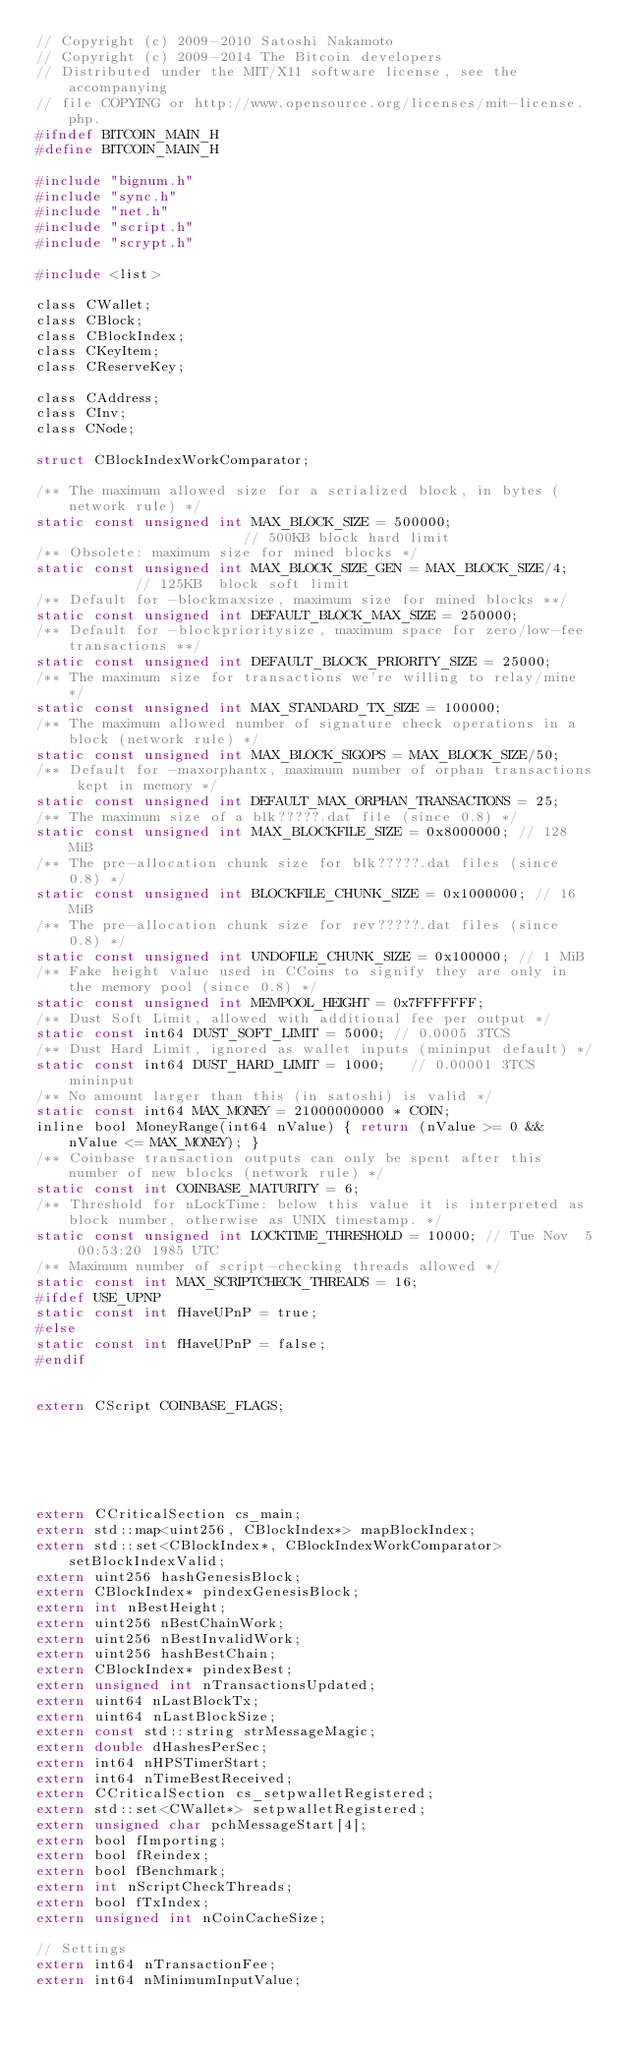<code> <loc_0><loc_0><loc_500><loc_500><_C_>// Copyright (c) 2009-2010 Satoshi Nakamoto
// Copyright (c) 2009-2014 The Bitcoin developers
// Distributed under the MIT/X11 software license, see the accompanying
// file COPYING or http://www.opensource.org/licenses/mit-license.php.
#ifndef BITCOIN_MAIN_H
#define BITCOIN_MAIN_H

#include "bignum.h"
#include "sync.h"
#include "net.h"
#include "script.h"
#include "scrypt.h"

#include <list>

class CWallet;
class CBlock;
class CBlockIndex;
class CKeyItem;
class CReserveKey;

class CAddress;
class CInv;
class CNode;

struct CBlockIndexWorkComparator;

/** The maximum allowed size for a serialized block, in bytes (network rule) */
static const unsigned int MAX_BLOCK_SIZE = 500000;                      // 500KB block hard limit
/** Obsolete: maximum size for mined blocks */
static const unsigned int MAX_BLOCK_SIZE_GEN = MAX_BLOCK_SIZE/4;         // 125KB  block soft limit
/** Default for -blockmaxsize, maximum size for mined blocks **/
static const unsigned int DEFAULT_BLOCK_MAX_SIZE = 250000;
/** Default for -blockprioritysize, maximum space for zero/low-fee transactions **/
static const unsigned int DEFAULT_BLOCK_PRIORITY_SIZE = 25000;
/** The maximum size for transactions we're willing to relay/mine */
static const unsigned int MAX_STANDARD_TX_SIZE = 100000;
/** The maximum allowed number of signature check operations in a block (network rule) */
static const unsigned int MAX_BLOCK_SIGOPS = MAX_BLOCK_SIZE/50;
/** Default for -maxorphantx, maximum number of orphan transactions kept in memory */
static const unsigned int DEFAULT_MAX_ORPHAN_TRANSACTIONS = 25;
/** The maximum size of a blk?????.dat file (since 0.8) */
static const unsigned int MAX_BLOCKFILE_SIZE = 0x8000000; // 128 MiB
/** The pre-allocation chunk size for blk?????.dat files (since 0.8) */
static const unsigned int BLOCKFILE_CHUNK_SIZE = 0x1000000; // 16 MiB
/** The pre-allocation chunk size for rev?????.dat files (since 0.8) */
static const unsigned int UNDOFILE_CHUNK_SIZE = 0x100000; // 1 MiB
/** Fake height value used in CCoins to signify they are only in the memory pool (since 0.8) */
static const unsigned int MEMPOOL_HEIGHT = 0x7FFFFFFF;
/** Dust Soft Limit, allowed with additional fee per output */
static const int64 DUST_SOFT_LIMIT = 5000; // 0.0005 3TCS
/** Dust Hard Limit, ignored as wallet inputs (mininput default) */
static const int64 DUST_HARD_LIMIT = 1000;   // 0.00001 3TCS mininput
/** No amount larger than this (in satoshi) is valid */
static const int64 MAX_MONEY = 21000000000 * COIN;
inline bool MoneyRange(int64 nValue) { return (nValue >= 0 && nValue <= MAX_MONEY); }
/** Coinbase transaction outputs can only be spent after this number of new blocks (network rule) */
static const int COINBASE_MATURITY = 6;
/** Threshold for nLockTime: below this value it is interpreted as block number, otherwise as UNIX timestamp. */
static const unsigned int LOCKTIME_THRESHOLD = 10000; // Tue Nov  5 00:53:20 1985 UTC
/** Maximum number of script-checking threads allowed */
static const int MAX_SCRIPTCHECK_THREADS = 16;
#ifdef USE_UPNP
static const int fHaveUPnP = true;
#else
static const int fHaveUPnP = false;
#endif


extern CScript COINBASE_FLAGS;






extern CCriticalSection cs_main;
extern std::map<uint256, CBlockIndex*> mapBlockIndex;
extern std::set<CBlockIndex*, CBlockIndexWorkComparator> setBlockIndexValid;
extern uint256 hashGenesisBlock;
extern CBlockIndex* pindexGenesisBlock;
extern int nBestHeight;
extern uint256 nBestChainWork;
extern uint256 nBestInvalidWork;
extern uint256 hashBestChain;
extern CBlockIndex* pindexBest;
extern unsigned int nTransactionsUpdated;
extern uint64 nLastBlockTx;
extern uint64 nLastBlockSize;
extern const std::string strMessageMagic;
extern double dHashesPerSec;
extern int64 nHPSTimerStart;
extern int64 nTimeBestReceived;
extern CCriticalSection cs_setpwalletRegistered;
extern std::set<CWallet*> setpwalletRegistered;
extern unsigned char pchMessageStart[4];
extern bool fImporting;
extern bool fReindex;
extern bool fBenchmark;
extern int nScriptCheckThreads;
extern bool fTxIndex;
extern unsigned int nCoinCacheSize;

// Settings
extern int64 nTransactionFee;
extern int64 nMinimumInputValue;
</code> 